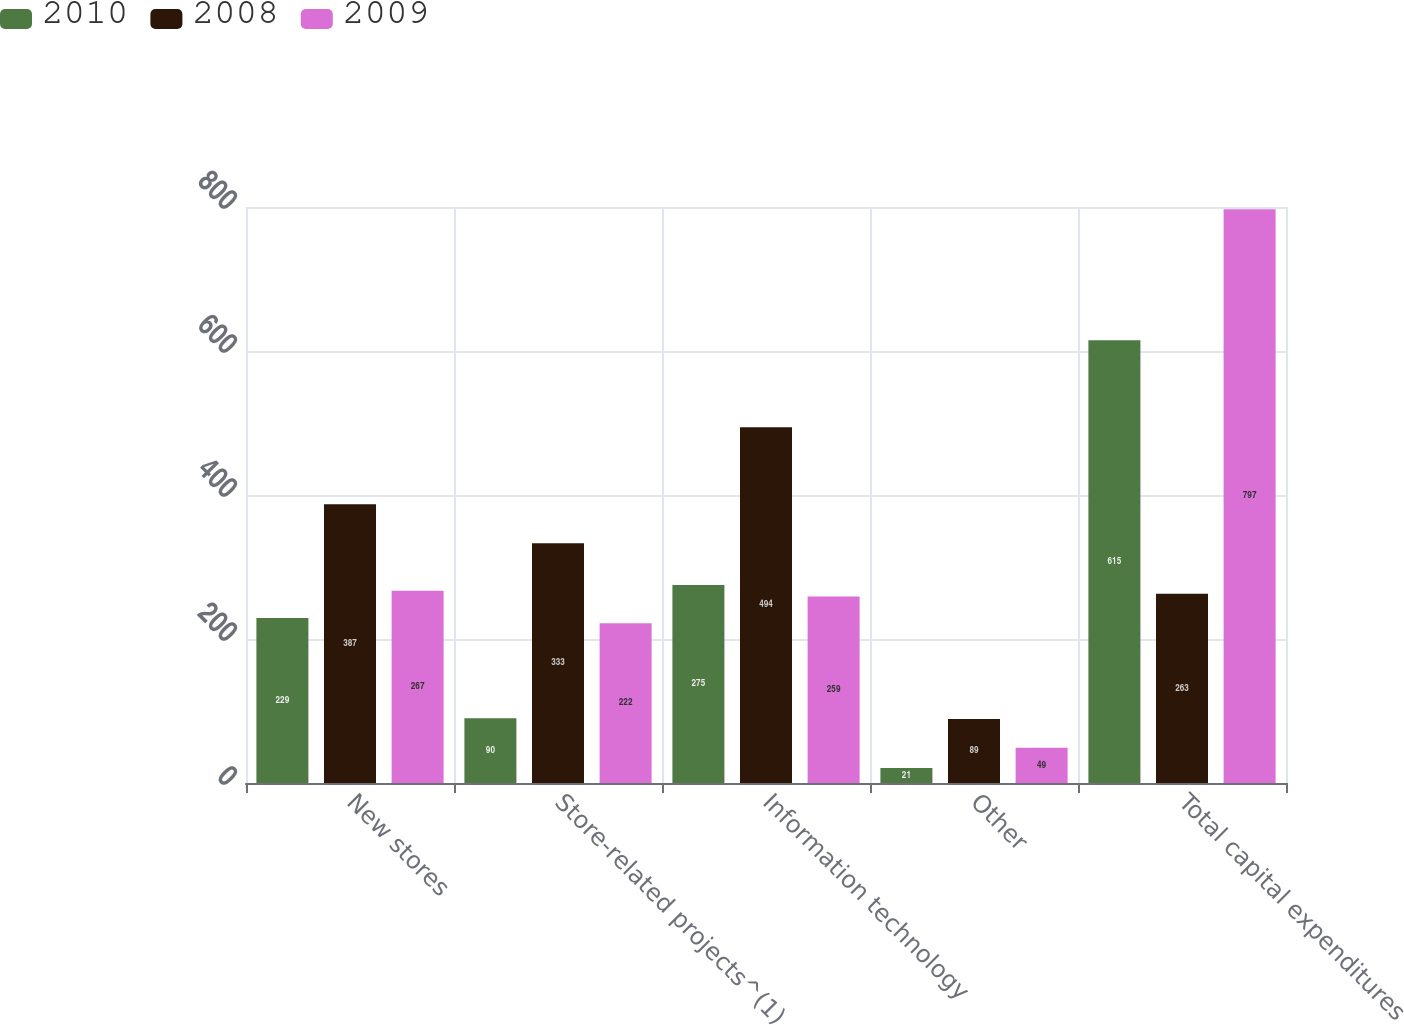Convert chart to OTSL. <chart><loc_0><loc_0><loc_500><loc_500><stacked_bar_chart><ecel><fcel>New stores<fcel>Store-related projects^(1)<fcel>Information technology<fcel>Other<fcel>Total capital expenditures<nl><fcel>2010<fcel>229<fcel>90<fcel>275<fcel>21<fcel>615<nl><fcel>2008<fcel>387<fcel>333<fcel>494<fcel>89<fcel>263<nl><fcel>2009<fcel>267<fcel>222<fcel>259<fcel>49<fcel>797<nl></chart> 